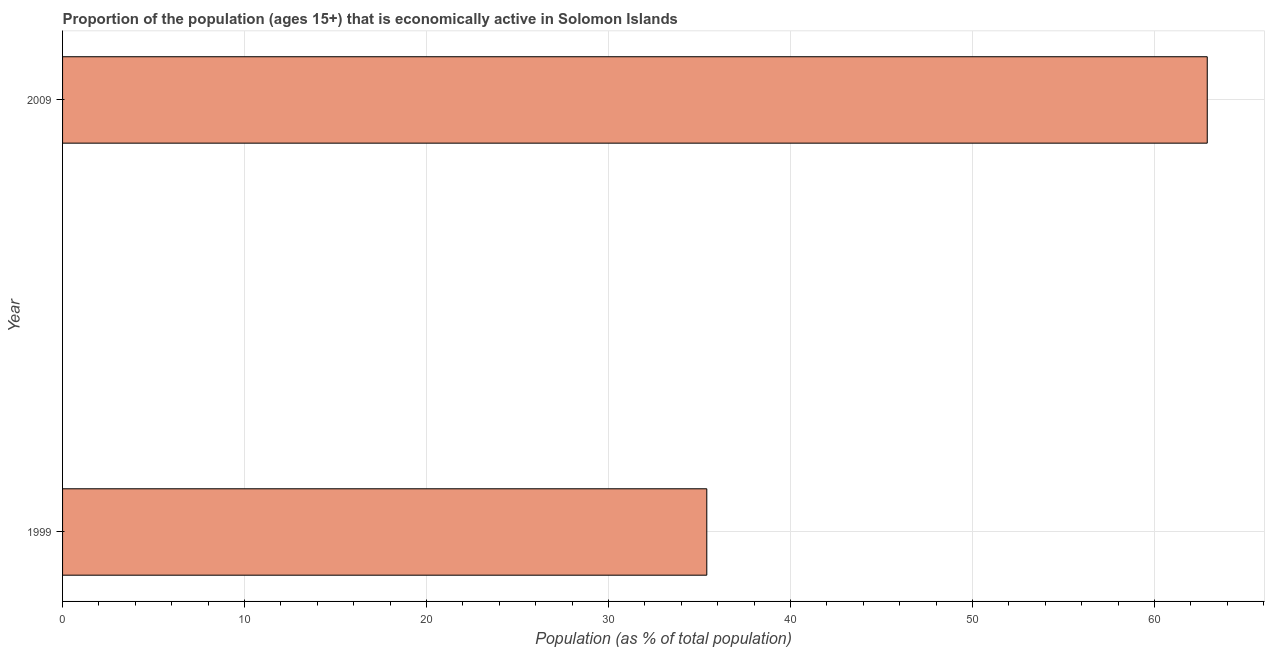Does the graph contain grids?
Your answer should be compact. Yes. What is the title of the graph?
Give a very brief answer. Proportion of the population (ages 15+) that is economically active in Solomon Islands. What is the label or title of the X-axis?
Keep it short and to the point. Population (as % of total population). What is the label or title of the Y-axis?
Your answer should be compact. Year. What is the percentage of economically active population in 2009?
Your answer should be very brief. 62.9. Across all years, what is the maximum percentage of economically active population?
Your response must be concise. 62.9. Across all years, what is the minimum percentage of economically active population?
Provide a succinct answer. 35.4. In which year was the percentage of economically active population maximum?
Offer a very short reply. 2009. In which year was the percentage of economically active population minimum?
Offer a very short reply. 1999. What is the sum of the percentage of economically active population?
Provide a short and direct response. 98.3. What is the difference between the percentage of economically active population in 1999 and 2009?
Give a very brief answer. -27.5. What is the average percentage of economically active population per year?
Ensure brevity in your answer.  49.15. What is the median percentage of economically active population?
Keep it short and to the point. 49.15. What is the ratio of the percentage of economically active population in 1999 to that in 2009?
Your answer should be very brief. 0.56. Is the percentage of economically active population in 1999 less than that in 2009?
Your response must be concise. Yes. In how many years, is the percentage of economically active population greater than the average percentage of economically active population taken over all years?
Ensure brevity in your answer.  1. Are all the bars in the graph horizontal?
Your answer should be compact. Yes. How many years are there in the graph?
Your answer should be compact. 2. What is the Population (as % of total population) of 1999?
Offer a terse response. 35.4. What is the Population (as % of total population) in 2009?
Give a very brief answer. 62.9. What is the difference between the Population (as % of total population) in 1999 and 2009?
Your answer should be very brief. -27.5. What is the ratio of the Population (as % of total population) in 1999 to that in 2009?
Ensure brevity in your answer.  0.56. 